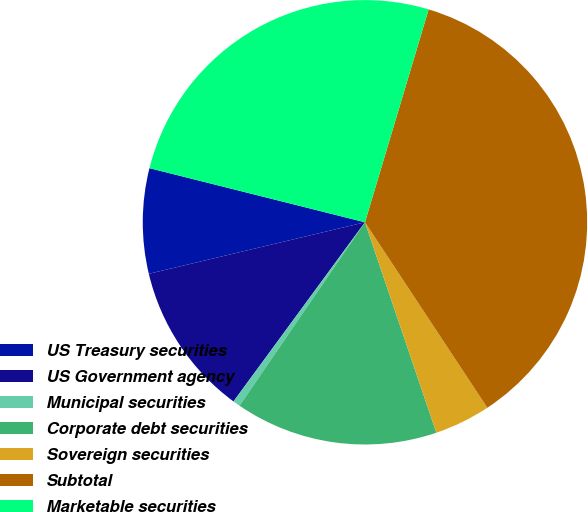Convert chart. <chart><loc_0><loc_0><loc_500><loc_500><pie_chart><fcel>US Treasury securities<fcel>US Government agency<fcel>Municipal securities<fcel>Corporate debt securities<fcel>Sovereign securities<fcel>Subtotal<fcel>Marketable securities<nl><fcel>7.64%<fcel>11.2%<fcel>0.53%<fcel>14.75%<fcel>4.08%<fcel>36.09%<fcel>25.71%<nl></chart> 